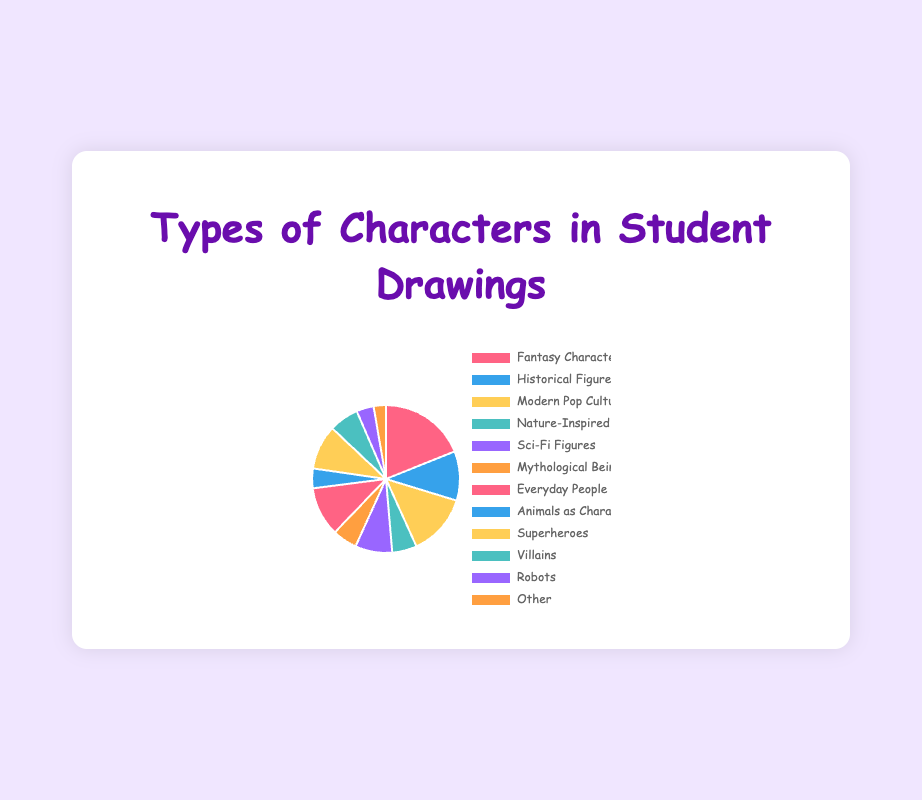Which type of characters is depicted most frequently in student drawings? To find the most frequently depicted type of character, look for the category with the largest slice in the pie chart. The largest slice corresponds to "Fantasy Characters."
Answer: Fantasy Characters How many more "Fantasy Characters" are there compared to "Robots"? To calculate the difference, subtract the number of "Robots" from the number of "Fantasy Characters." That's 35 (Fantasy Characters) - 7 (Robots) = 28.
Answer: 28 What percentage of student drawings depict "Modern Pop Culture Icons"? Look at the slice in the pie chart labeled "Modern Pop Culture Icons" and its percentage value. The percentage displays 25%.
Answer: 25% Are there more "Superheroes" or "Villains"? Compare the sizes of the slices labeled "Superheroes" and "Villains." There are 18 "Superheroes" and 12 "Villains," so there are more "Superheroes."
Answer: Superheroes What's the combined percentage of "Historical Figures" and "Everyday People"? Sum the numbers for "Historical Figures" and "Everyday People" (20 + 20) and then calculate the percentage (40 out of the total sum 185). The exact percentage calculation requires summing the other categories and normalizing. Given these values, a quick estimate in the chart shows it's around 22%.
Answer: 22% Which category has the smallest number of entries, and what is that number? Look for the smallest slice in the pie chart, labeled "Other," which has 5 entries.
Answer: Other: 5 If you combine "Sci-Fi Figures" and "Mythological Beings," do they account for more or fewer drawings than "Modern Pop Culture Icons"? Add the numbers for "Sci-Fi Figures" and "Mythological Beings" (15 + 10 = 25) and compare them to the number for "Modern Pop Culture Icons" (25). They account for the same number.
Answer: Same Name two categories that have an equal number of depictions. Look for slices in the pie chart that are the same size. Both "Nature-Inspired Characters" and "Mythological Beings" have 10 each.
Answer: Nature-Inspired Characters, Mythological Beings What is the total number of "Fantasy Characters", "Superheroes", and "Villains"? Add the numbers for "Fantasy Characters," "Superheroes," and "Villains" (35 + 18 + 12 = 65).
Answer: 65 